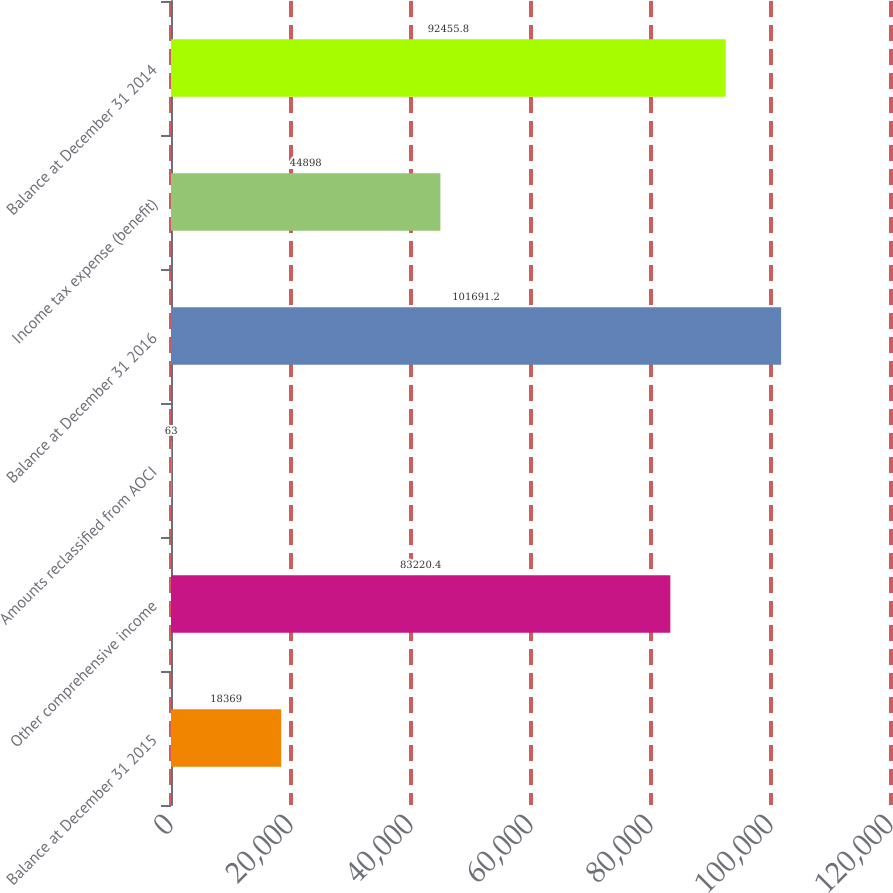<chart> <loc_0><loc_0><loc_500><loc_500><bar_chart><fcel>Balance at December 31 2015<fcel>Other comprehensive income<fcel>Amounts reclassified from AOCI<fcel>Balance at December 31 2016<fcel>Income tax expense (benefit)<fcel>Balance at December 31 2014<nl><fcel>18369<fcel>83220.4<fcel>63<fcel>101691<fcel>44898<fcel>92455.8<nl></chart> 